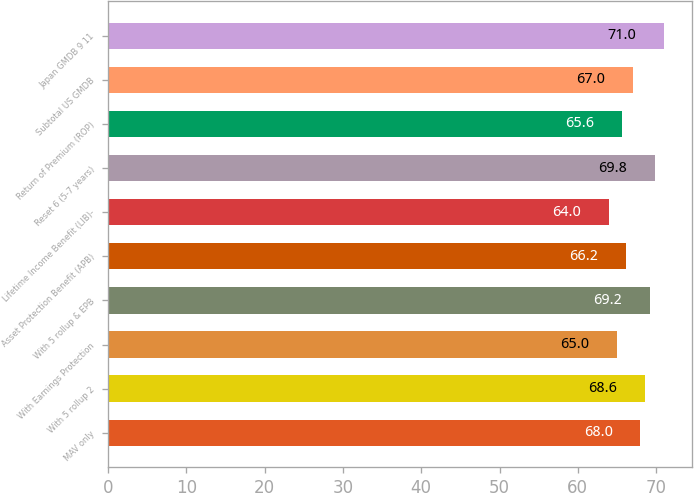Convert chart. <chart><loc_0><loc_0><loc_500><loc_500><bar_chart><fcel>MAV only<fcel>With 5 rollup 2<fcel>With Earnings Protection<fcel>With 5 rollup & EPB<fcel>Asset Protection Benefit (APB)<fcel>Lifetime Income Benefit (LIB)-<fcel>Reset 6 (5-7 years)<fcel>Return of Premium (ROP)<fcel>Subtotal US GMDB<fcel>Japan GMDB 9 11<nl><fcel>68<fcel>68.6<fcel>65<fcel>69.2<fcel>66.2<fcel>64<fcel>69.8<fcel>65.6<fcel>67<fcel>71<nl></chart> 